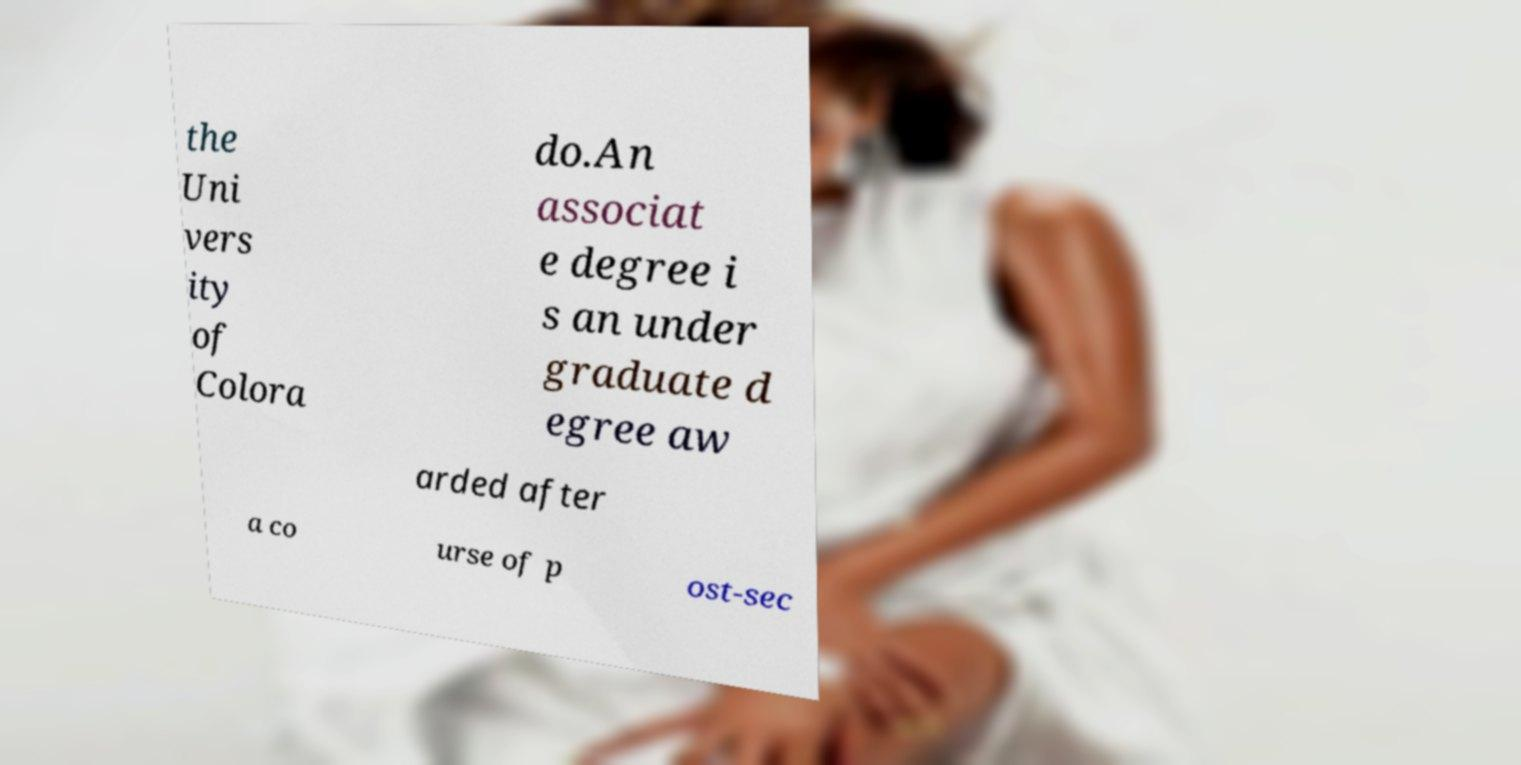Can you accurately transcribe the text from the provided image for me? the Uni vers ity of Colora do.An associat e degree i s an under graduate d egree aw arded after a co urse of p ost-sec 